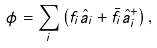Convert formula to latex. <formula><loc_0><loc_0><loc_500><loc_500>\phi = \sum _ { i } \left ( f _ { i } \hat { a } _ { i } + \bar { f } _ { i } \hat { a } _ { i } ^ { + } \right ) ,</formula> 